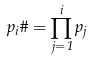<formula> <loc_0><loc_0><loc_500><loc_500>p _ { i } \# = \prod _ { j = 1 } ^ { i } p _ { j }</formula> 